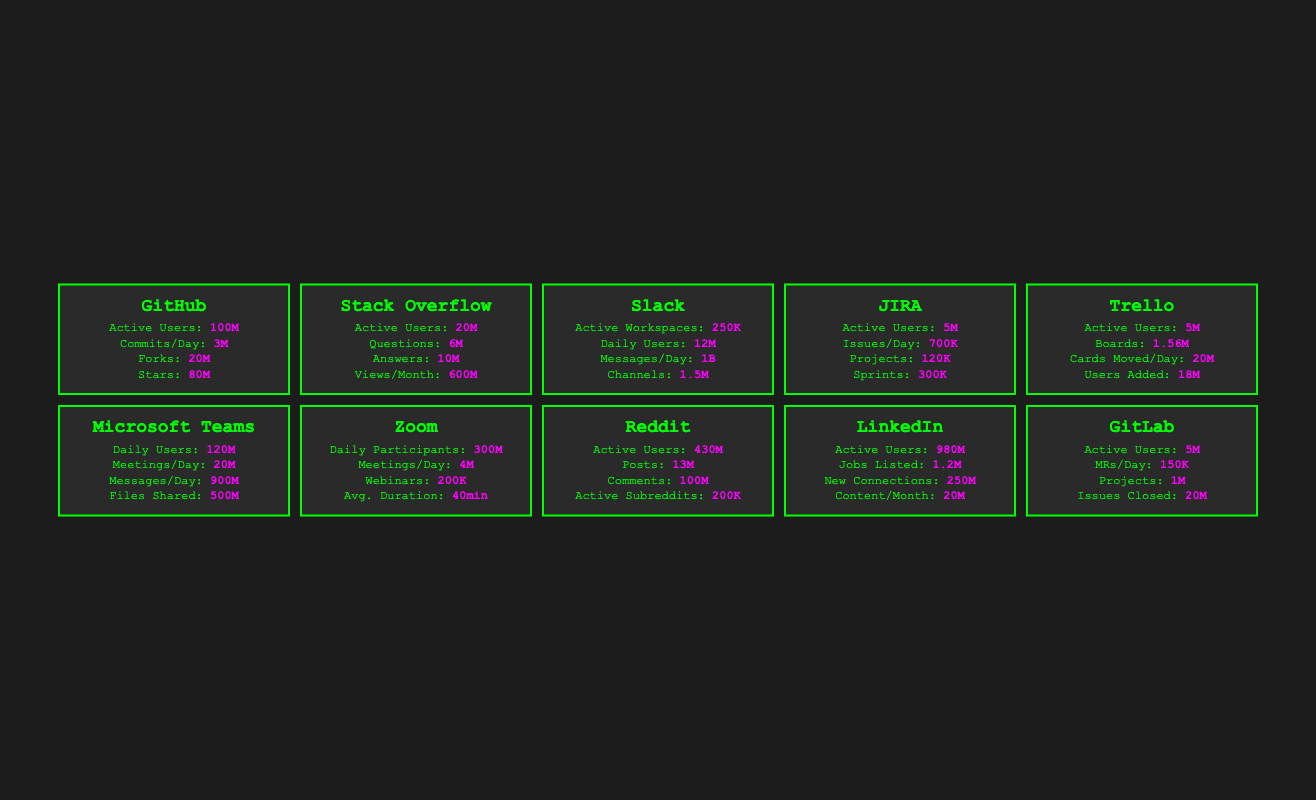What is the number of Active Users on GitHub? According to the table, the Active Users on GitHub is clearly stated as 100,000,000.
Answer: 100M How many Questions were asked on Stack Overflow? The table lists that the Questions Asked on Stack Overflow is 6,000,000.
Answer: 6M Is the number of Active Users on LinkedIn greater than that on Reddit? LinkedIn has 980,000,000 Active Users and Reddit has 430,000,000 Active Users. Since 980M is greater than 430M, the answer is yes.
Answer: Yes What is the total number of Daily Active Users for Slack and Microsoft Teams combined? Slack has 12,000,000 Daily Active Users and Microsoft Teams has 120,000,000 Daily Active Users. The total is 12M + 120M = 132M.
Answer: 132M Which platform has the most Files Shared per day? The value for Files Shared is given for Microsoft Teams as 500,000,000, which is the highest when compared to other platforms listed.
Answer: Microsoft Teams What is the average number of Messages Sent per Day across Slack, Microsoft Teams, and Zoom? The table shows Slack with 1,000,000,000 Messages/Day, Microsoft Teams with 900,000,000 Messages/Day, and Zoom does not provide that metric directly; however, we can average the first two: (1B + 900M) / 2 = 950M for just Slack and Teams. Zoom's Meetings Held per Day does not contribute to this directly.
Answer: 950M How many more Posts were created on Reddit than Issues created on JIRA? Reddit created 13,000,000 Posts, while JIRA had 700,000 Issues created per day. To find the difference: 13M - 0.7M = 12.3M.
Answer: 12.3M Is it true that the number of New Connections made on LinkedIn exceeds Jobs Listed? LinkedIn shows 250,000,000 New Connections and 1,200,000 Jobs Listed. Since 250M > 1.2M, the statement is true.
Answer: Yes Which platform has the highest number of Commits per Day? The table specifies that GitHub has 3,000,000 Commits per Day, and no other platform listed has comparable data for commits.
Answer: GitHub 